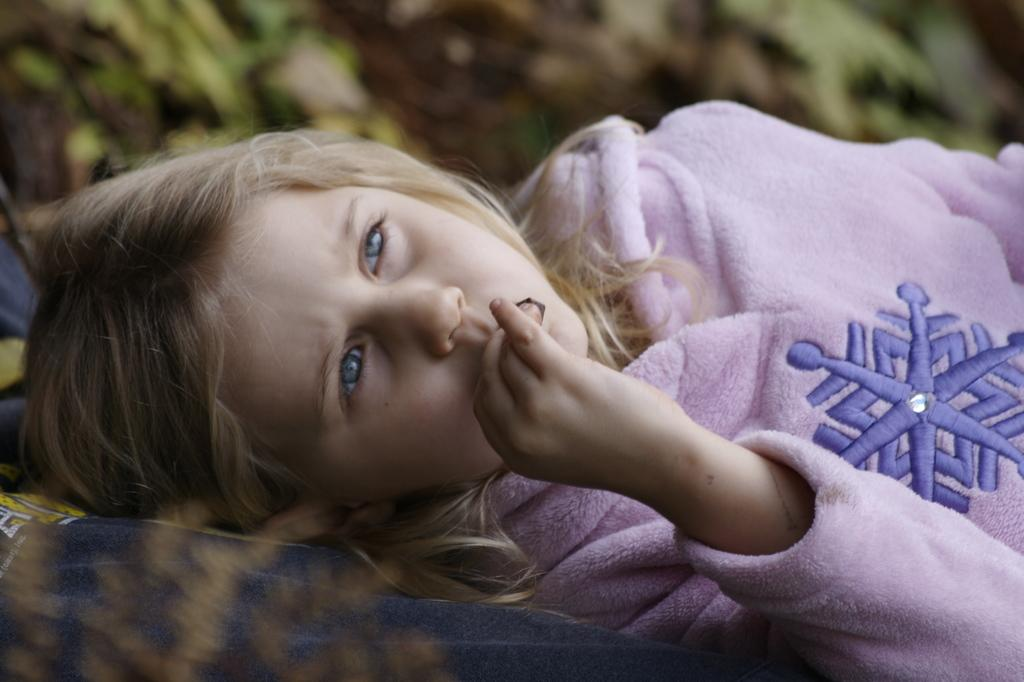What is the main subject of the image? There is a child in the image. What is the child doing in the image? The child is lying down. What type of discussion is the child having with the dogs in the image? There are no dogs present in the image, and therefore no discussion can be observed. 